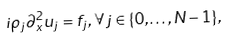Convert formula to latex. <formula><loc_0><loc_0><loc_500><loc_500>i \rho _ { j } \partial _ { x } ^ { 2 } u _ { j } = f _ { j } , \, \forall j \in \{ 0 , \dots , N - 1 \} ,</formula> 